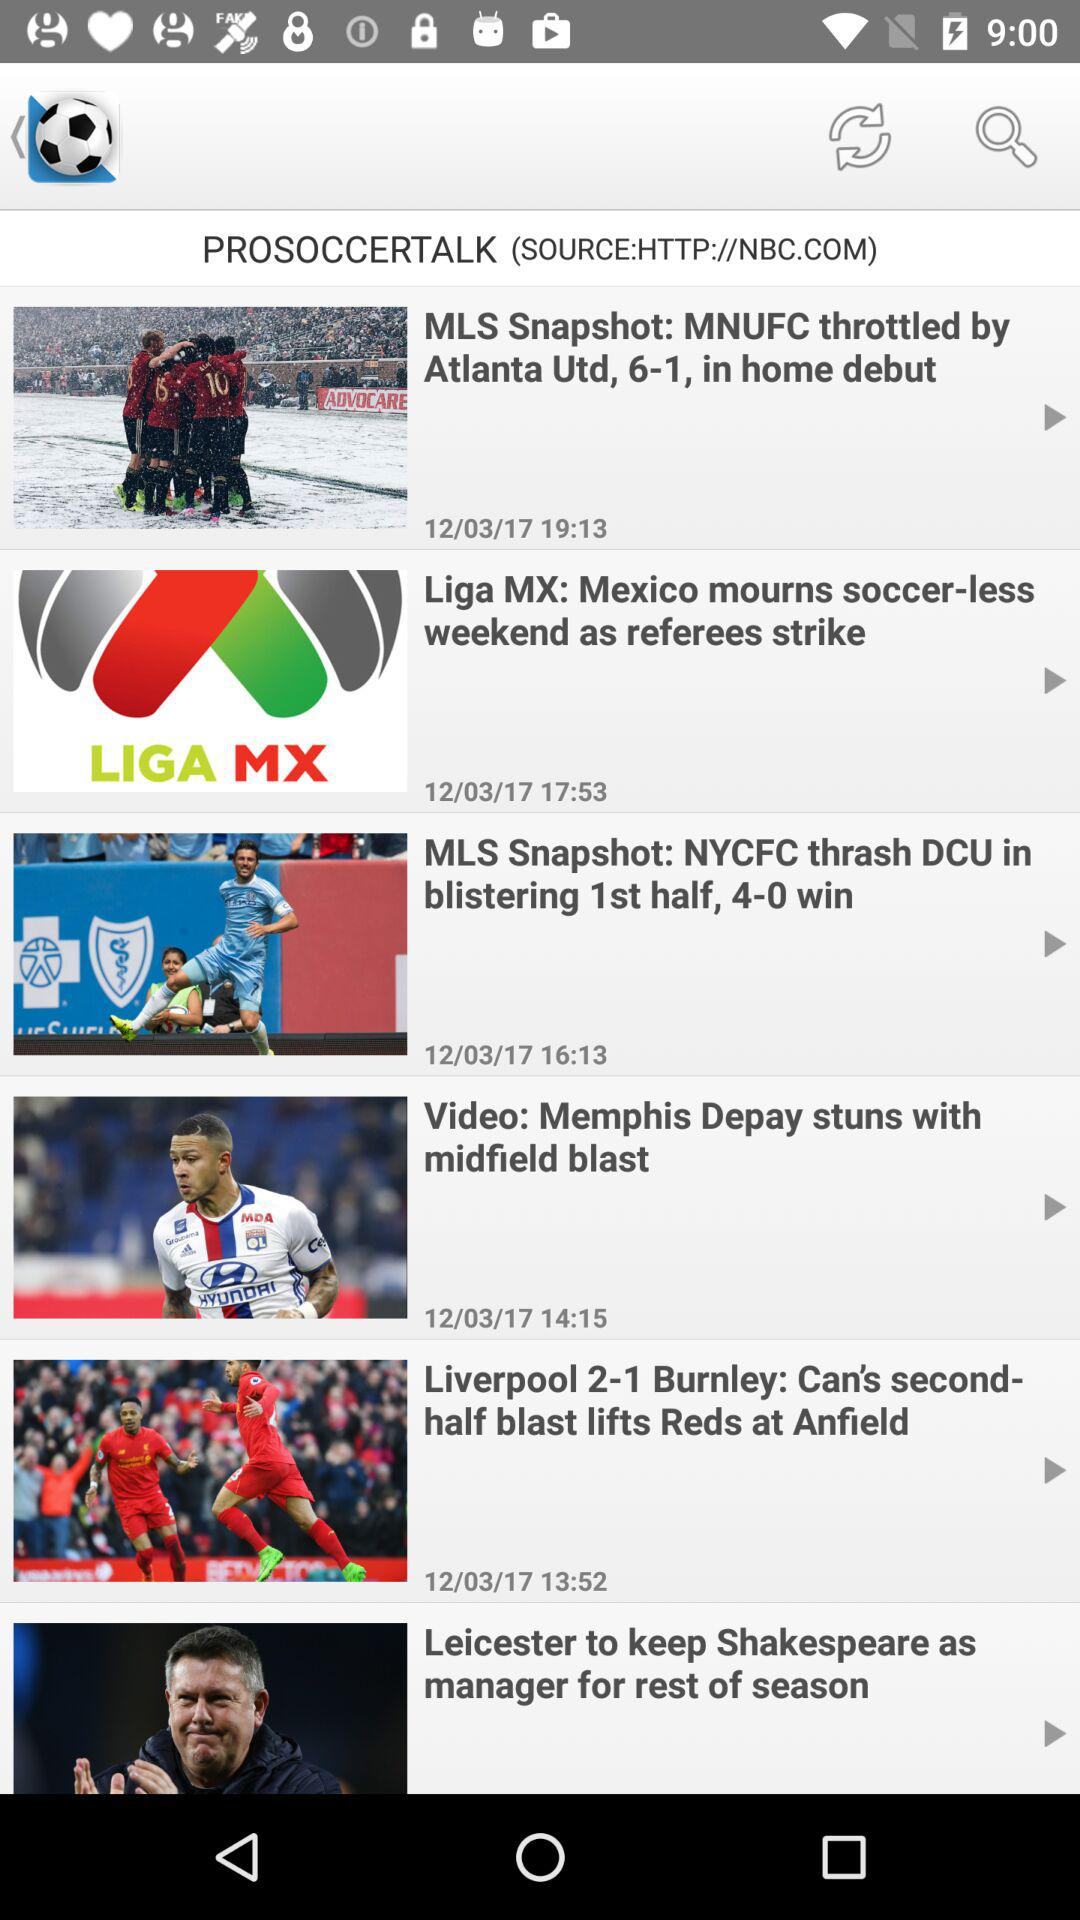When was the "MLS Snapshot: NYCFC thrash DCU in blistering 1st half, 4-0 win" published? The published date is December 2, 2017. 